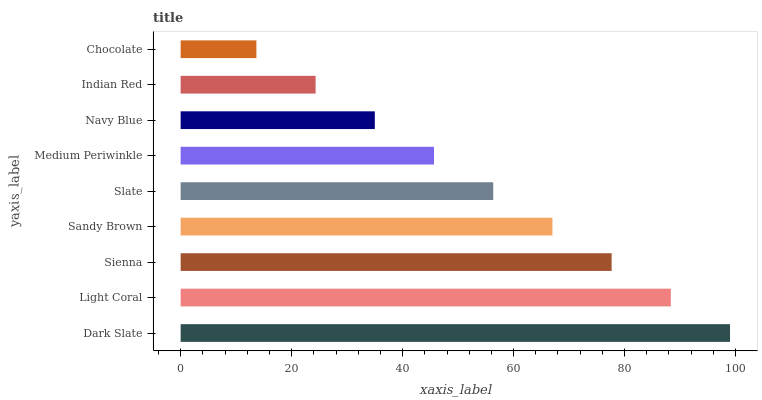Is Chocolate the minimum?
Answer yes or no. Yes. Is Dark Slate the maximum?
Answer yes or no. Yes. Is Light Coral the minimum?
Answer yes or no. No. Is Light Coral the maximum?
Answer yes or no. No. Is Dark Slate greater than Light Coral?
Answer yes or no. Yes. Is Light Coral less than Dark Slate?
Answer yes or no. Yes. Is Light Coral greater than Dark Slate?
Answer yes or no. No. Is Dark Slate less than Light Coral?
Answer yes or no. No. Is Slate the high median?
Answer yes or no. Yes. Is Slate the low median?
Answer yes or no. Yes. Is Medium Periwinkle the high median?
Answer yes or no. No. Is Dark Slate the low median?
Answer yes or no. No. 